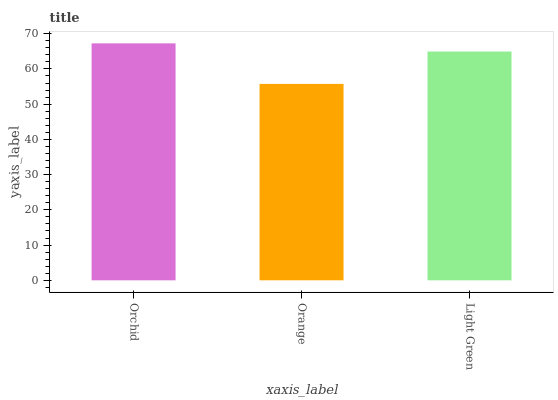Is Orange the minimum?
Answer yes or no. Yes. Is Orchid the maximum?
Answer yes or no. Yes. Is Light Green the minimum?
Answer yes or no. No. Is Light Green the maximum?
Answer yes or no. No. Is Light Green greater than Orange?
Answer yes or no. Yes. Is Orange less than Light Green?
Answer yes or no. Yes. Is Orange greater than Light Green?
Answer yes or no. No. Is Light Green less than Orange?
Answer yes or no. No. Is Light Green the high median?
Answer yes or no. Yes. Is Light Green the low median?
Answer yes or no. Yes. Is Orchid the high median?
Answer yes or no. No. Is Orchid the low median?
Answer yes or no. No. 